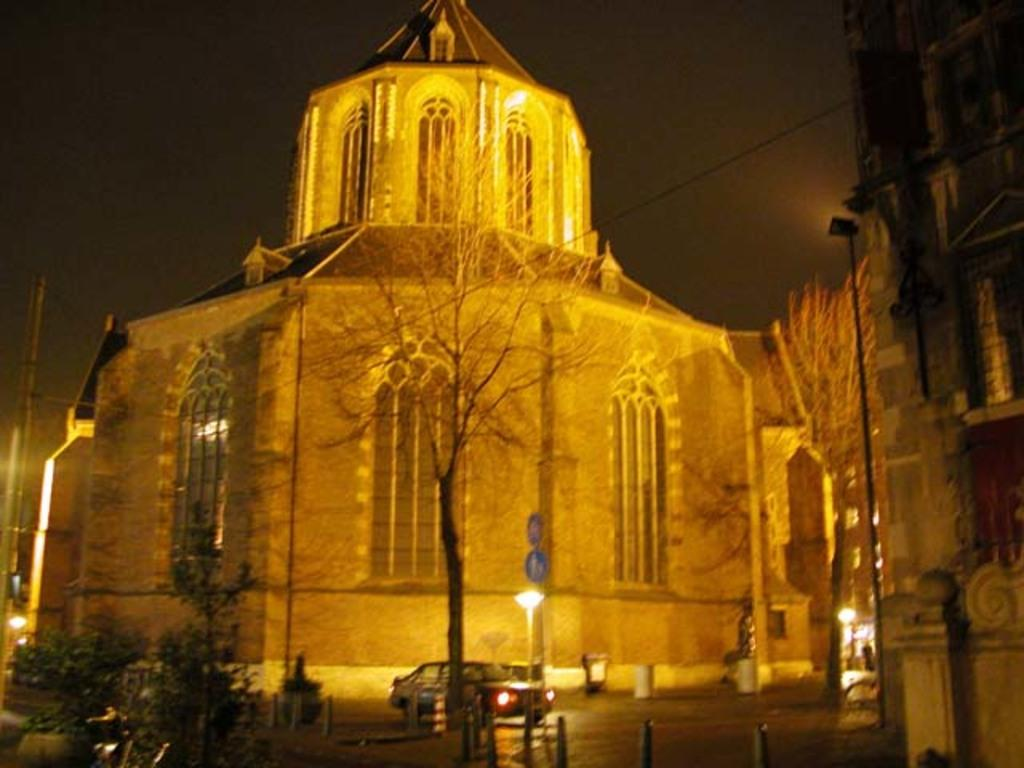What type of structure is visible in the image? There is a building in the image. What can be seen surrounding the building? There are trees around the building. What safety precaution is indicated in the image? Caution boards are present in the image. What type of transportation is visible in the image? There is a vehicle in the image. What type of fruit is being used to create a bed in the image? There is no fruit or bed present in the image. What type of prose is being recited by the trees in the image? There is no prose or recitation happening in the image; the trees are simply trees. 